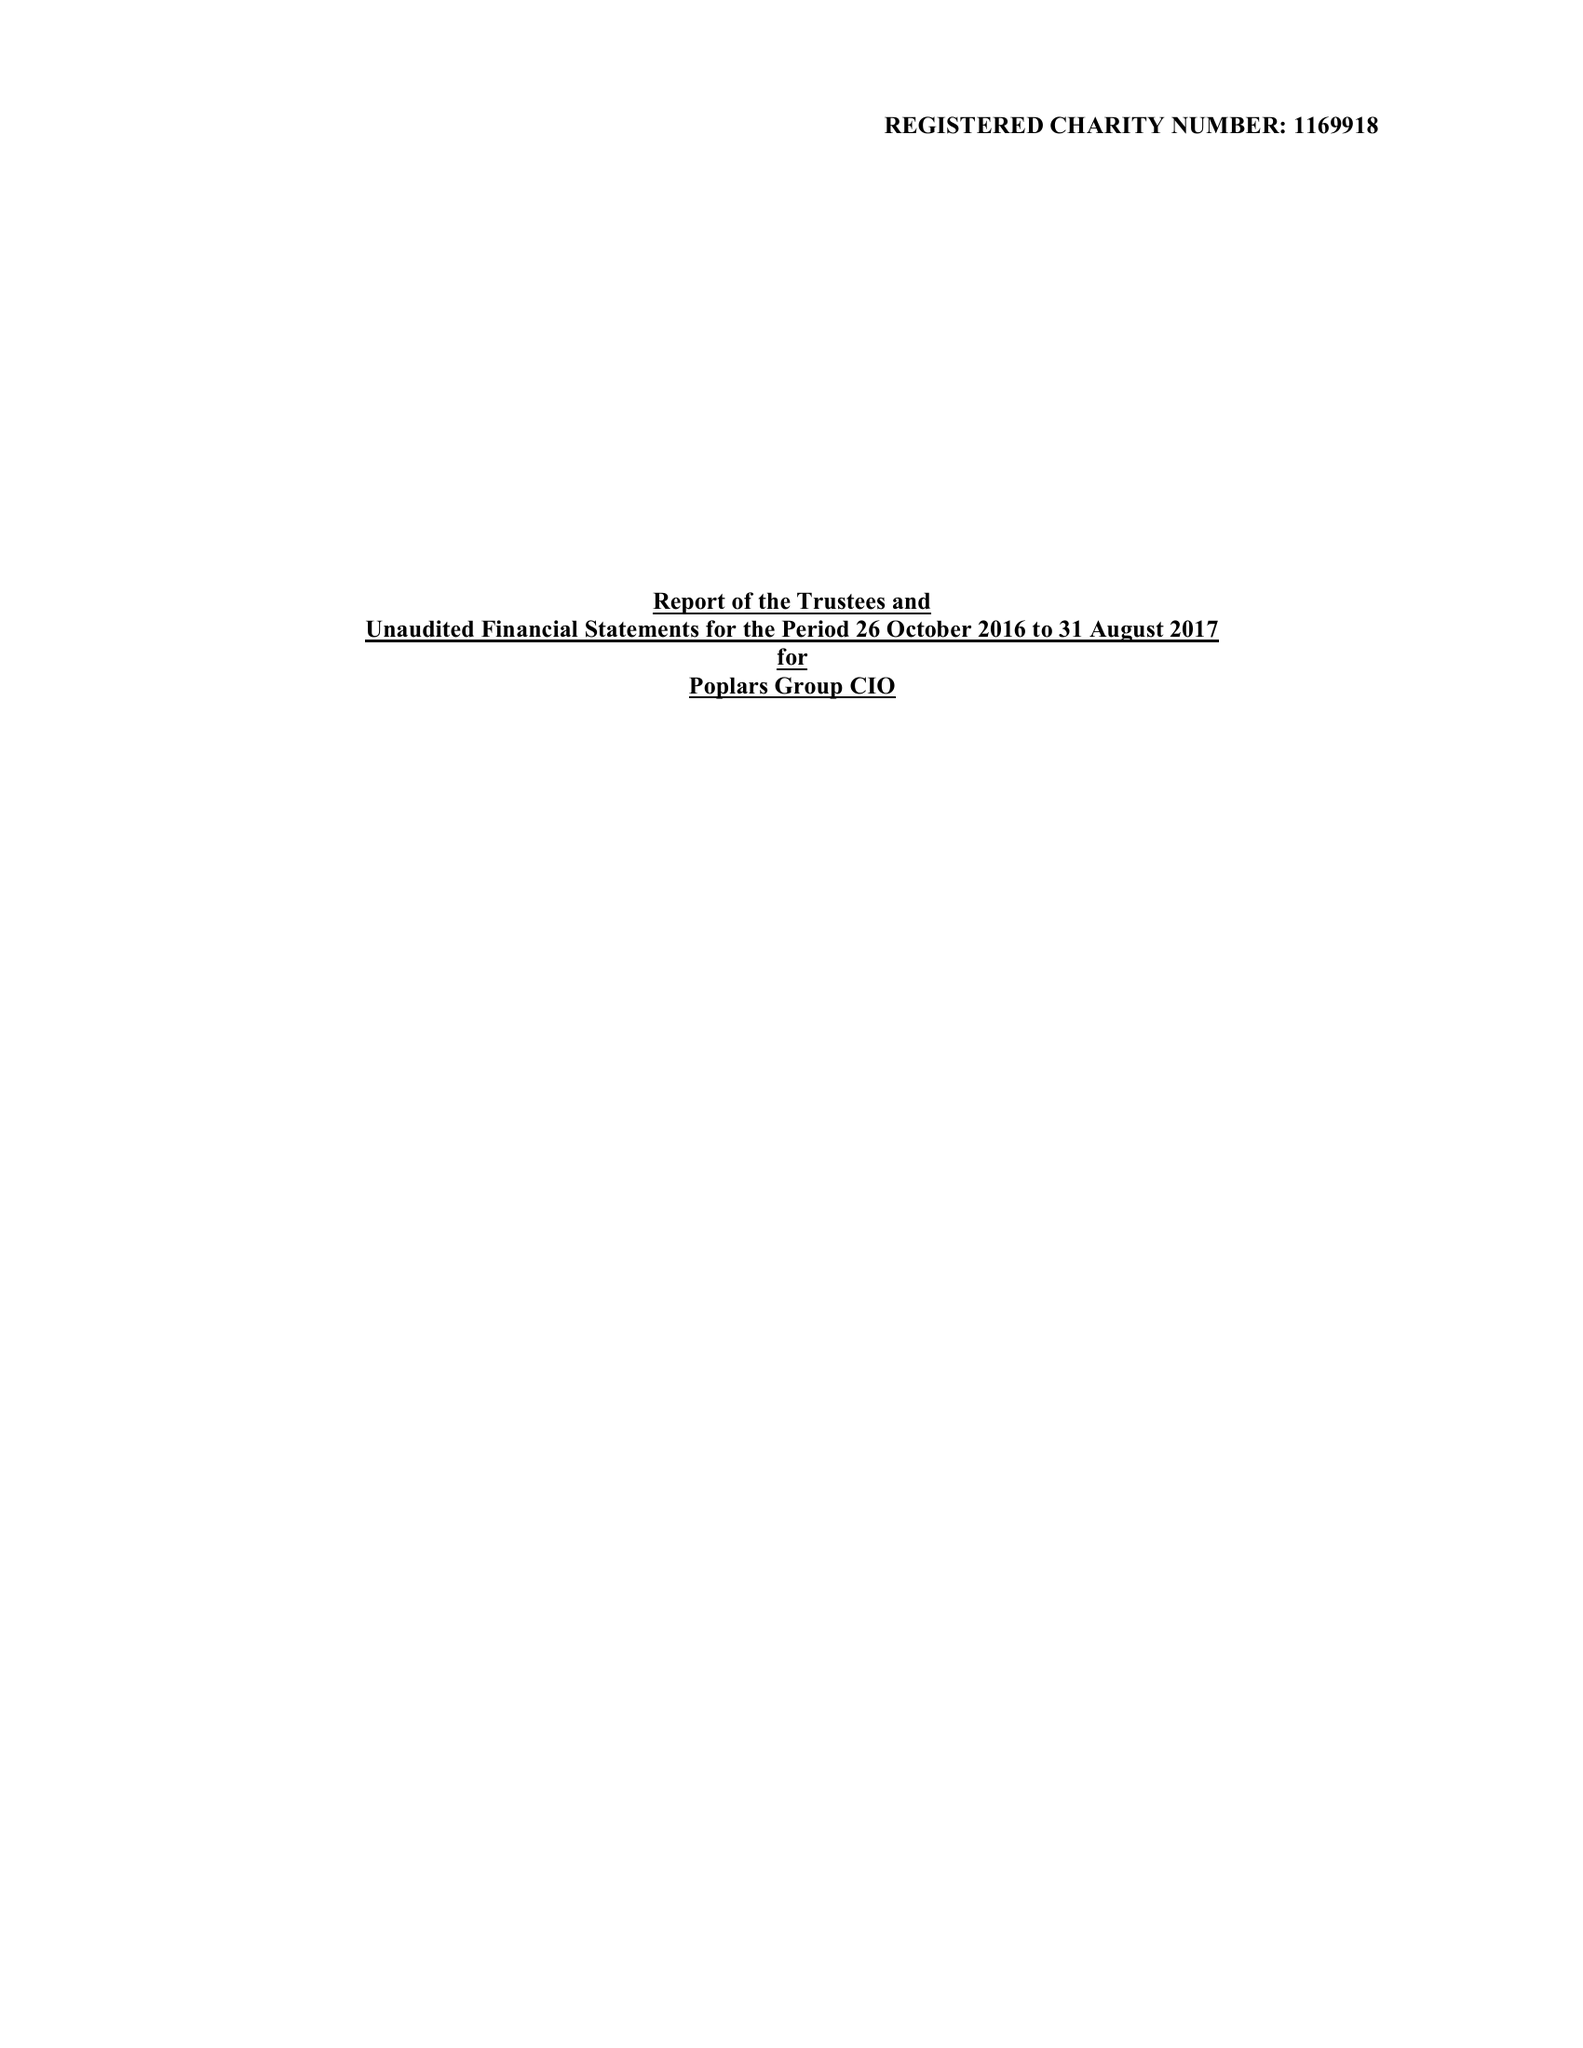What is the value for the address__street_line?
Answer the question using a single word or phrase. 53 BRAMCOTE ROAD 